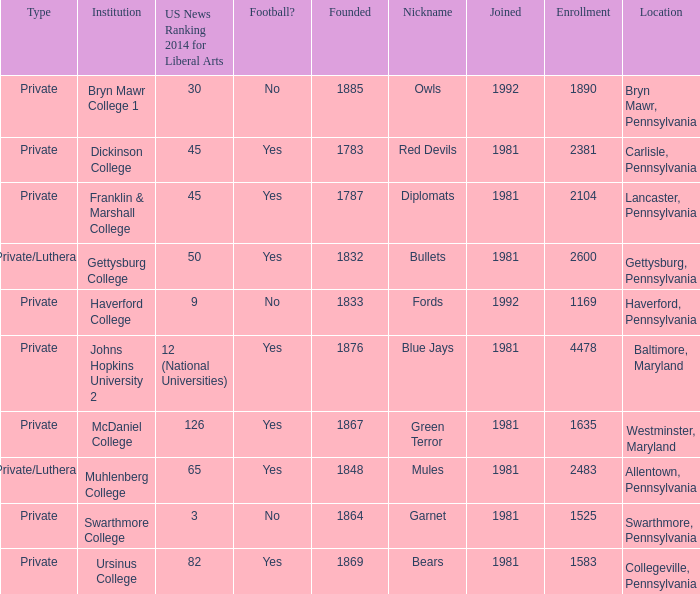When was Dickinson College founded? 1783.0. 